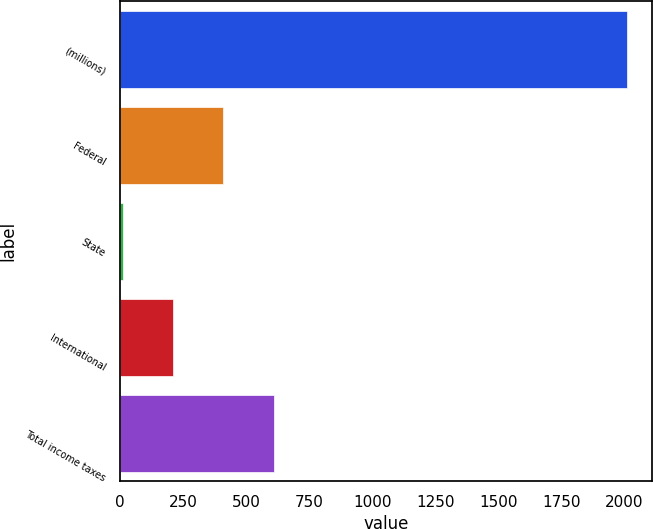Convert chart to OTSL. <chart><loc_0><loc_0><loc_500><loc_500><bar_chart><fcel>(millions)<fcel>Federal<fcel>State<fcel>International<fcel>Total income taxes<nl><fcel>2010<fcel>410.48<fcel>10.6<fcel>210.54<fcel>610.42<nl></chart> 